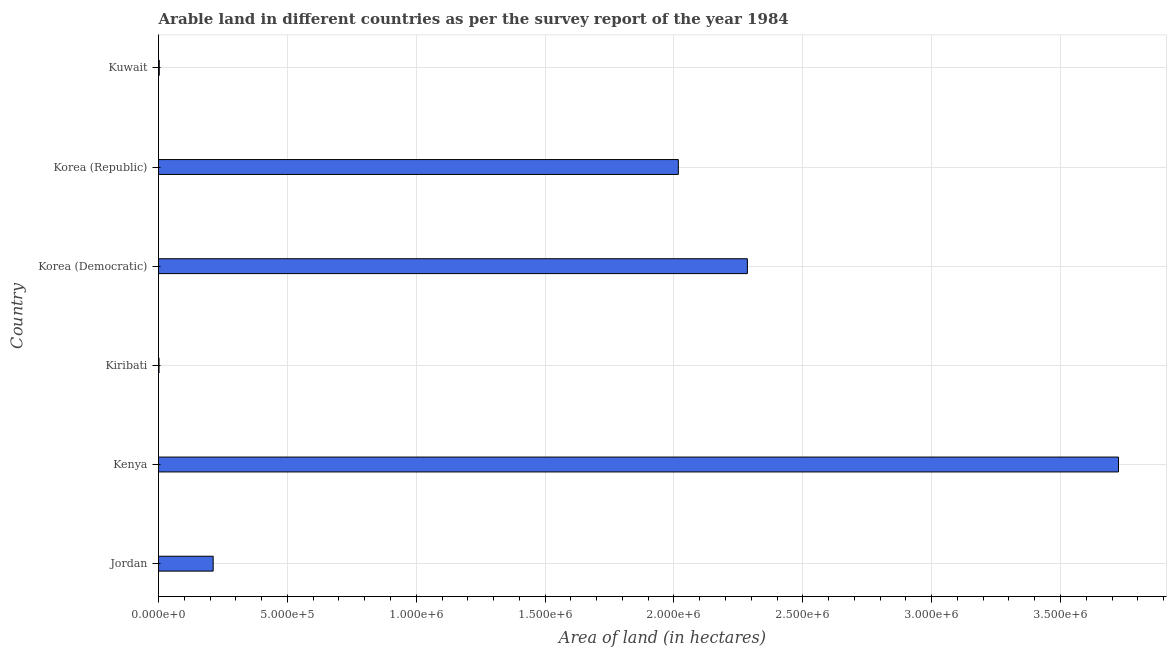Does the graph contain any zero values?
Keep it short and to the point. No. What is the title of the graph?
Your response must be concise. Arable land in different countries as per the survey report of the year 1984. What is the label or title of the X-axis?
Keep it short and to the point. Area of land (in hectares). What is the area of land in Kuwait?
Provide a succinct answer. 3000. Across all countries, what is the maximum area of land?
Ensure brevity in your answer.  3.72e+06. In which country was the area of land maximum?
Provide a short and direct response. Kenya. In which country was the area of land minimum?
Make the answer very short. Kiribati. What is the sum of the area of land?
Offer a very short reply. 8.24e+06. What is the difference between the area of land in Korea (Republic) and Kuwait?
Provide a short and direct response. 2.01e+06. What is the average area of land per country?
Offer a terse response. 1.37e+06. What is the median area of land?
Provide a succinct answer. 1.11e+06. What is the ratio of the area of land in Kenya to that in Kuwait?
Ensure brevity in your answer.  1241.67. Is the area of land in Korea (Democratic) less than that in Kuwait?
Your answer should be compact. No. Is the difference between the area of land in Kenya and Kiribati greater than the difference between any two countries?
Ensure brevity in your answer.  Yes. What is the difference between the highest and the second highest area of land?
Keep it short and to the point. 1.44e+06. Is the sum of the area of land in Kenya and Korea (Democratic) greater than the maximum area of land across all countries?
Ensure brevity in your answer.  Yes. What is the difference between the highest and the lowest area of land?
Give a very brief answer. 3.72e+06. In how many countries, is the area of land greater than the average area of land taken over all countries?
Your answer should be very brief. 3. How many bars are there?
Give a very brief answer. 6. What is the Area of land (in hectares) in Jordan?
Give a very brief answer. 2.12e+05. What is the Area of land (in hectares) in Kenya?
Ensure brevity in your answer.  3.72e+06. What is the Area of land (in hectares) of Kiribati?
Provide a short and direct response. 2000. What is the Area of land (in hectares) of Korea (Democratic)?
Provide a short and direct response. 2.28e+06. What is the Area of land (in hectares) of Korea (Republic)?
Your answer should be compact. 2.02e+06. What is the Area of land (in hectares) in Kuwait?
Provide a succinct answer. 3000. What is the difference between the Area of land (in hectares) in Jordan and Kenya?
Your answer should be very brief. -3.51e+06. What is the difference between the Area of land (in hectares) in Jordan and Kiribati?
Offer a very short reply. 2.10e+05. What is the difference between the Area of land (in hectares) in Jordan and Korea (Democratic)?
Provide a succinct answer. -2.07e+06. What is the difference between the Area of land (in hectares) in Jordan and Korea (Republic)?
Your answer should be very brief. -1.80e+06. What is the difference between the Area of land (in hectares) in Jordan and Kuwait?
Your answer should be very brief. 2.09e+05. What is the difference between the Area of land (in hectares) in Kenya and Kiribati?
Your answer should be compact. 3.72e+06. What is the difference between the Area of land (in hectares) in Kenya and Korea (Democratic)?
Your answer should be compact. 1.44e+06. What is the difference between the Area of land (in hectares) in Kenya and Korea (Republic)?
Provide a short and direct response. 1.71e+06. What is the difference between the Area of land (in hectares) in Kenya and Kuwait?
Provide a short and direct response. 3.72e+06. What is the difference between the Area of land (in hectares) in Kiribati and Korea (Democratic)?
Make the answer very short. -2.28e+06. What is the difference between the Area of land (in hectares) in Kiribati and Korea (Republic)?
Provide a succinct answer. -2.02e+06. What is the difference between the Area of land (in hectares) in Kiribati and Kuwait?
Keep it short and to the point. -1000. What is the difference between the Area of land (in hectares) in Korea (Democratic) and Korea (Republic)?
Your response must be concise. 2.68e+05. What is the difference between the Area of land (in hectares) in Korea (Democratic) and Kuwait?
Provide a succinct answer. 2.28e+06. What is the difference between the Area of land (in hectares) in Korea (Republic) and Kuwait?
Provide a succinct answer. 2.01e+06. What is the ratio of the Area of land (in hectares) in Jordan to that in Kenya?
Your response must be concise. 0.06. What is the ratio of the Area of land (in hectares) in Jordan to that in Kiribati?
Keep it short and to the point. 106.05. What is the ratio of the Area of land (in hectares) in Jordan to that in Korea (Democratic)?
Keep it short and to the point. 0.09. What is the ratio of the Area of land (in hectares) in Jordan to that in Korea (Republic)?
Your answer should be compact. 0.1. What is the ratio of the Area of land (in hectares) in Jordan to that in Kuwait?
Your answer should be compact. 70.7. What is the ratio of the Area of land (in hectares) in Kenya to that in Kiribati?
Provide a short and direct response. 1862.5. What is the ratio of the Area of land (in hectares) in Kenya to that in Korea (Democratic)?
Offer a very short reply. 1.63. What is the ratio of the Area of land (in hectares) in Kenya to that in Korea (Republic)?
Make the answer very short. 1.85. What is the ratio of the Area of land (in hectares) in Kenya to that in Kuwait?
Your answer should be compact. 1241.67. What is the ratio of the Area of land (in hectares) in Kiribati to that in Kuwait?
Your answer should be compact. 0.67. What is the ratio of the Area of land (in hectares) in Korea (Democratic) to that in Korea (Republic)?
Keep it short and to the point. 1.13. What is the ratio of the Area of land (in hectares) in Korea (Democratic) to that in Kuwait?
Keep it short and to the point. 761.67. What is the ratio of the Area of land (in hectares) in Korea (Republic) to that in Kuwait?
Your answer should be compact. 672.33. 